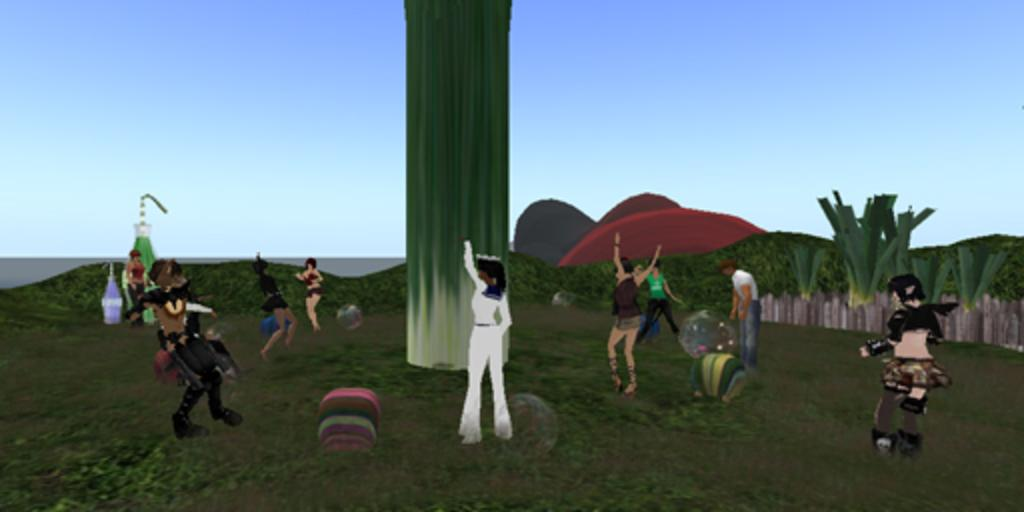What type of characters are present in the image? There are animated people in the image. How many animated people can be seen in the image? There are many people in the image. What type of natural elements are present in the image? There are trees in the image. What else can be seen in the image besides animated people and trees? There are objects in the image. What is the appearance of the sky in the image? The sky in the image appears to be animated. What is the purpose of the rail in the image? There is no rail present in the image. 